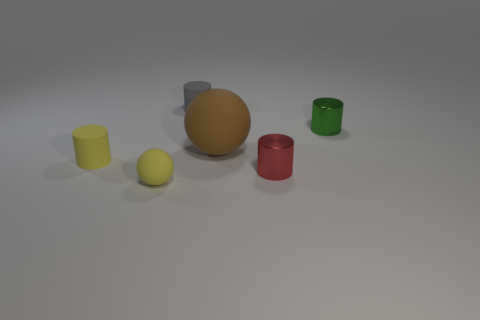Are the ball left of the brown matte object and the gray cylinder that is behind the large brown object made of the same material?
Offer a very short reply. Yes. What number of cyan objects are either tiny things or rubber cylinders?
Your answer should be very brief. 0. How big is the red object?
Provide a short and direct response. Small. Is the number of yellow spheres behind the big brown rubber ball greater than the number of tiny gray cylinders?
Provide a succinct answer. No. What number of tiny shiny objects are behind the brown thing?
Provide a succinct answer. 1. Is there a ball that has the same size as the brown object?
Your answer should be very brief. No. There is a small rubber object that is the same shape as the large object; what color is it?
Offer a terse response. Yellow. Does the yellow rubber thing on the left side of the tiny matte ball have the same size as the thing that is in front of the red metal cylinder?
Keep it short and to the point. Yes. Is there a large yellow thing that has the same shape as the green metal object?
Make the answer very short. No. Are there the same number of yellow objects that are on the left side of the small rubber ball and big yellow rubber spheres?
Your answer should be very brief. No. 